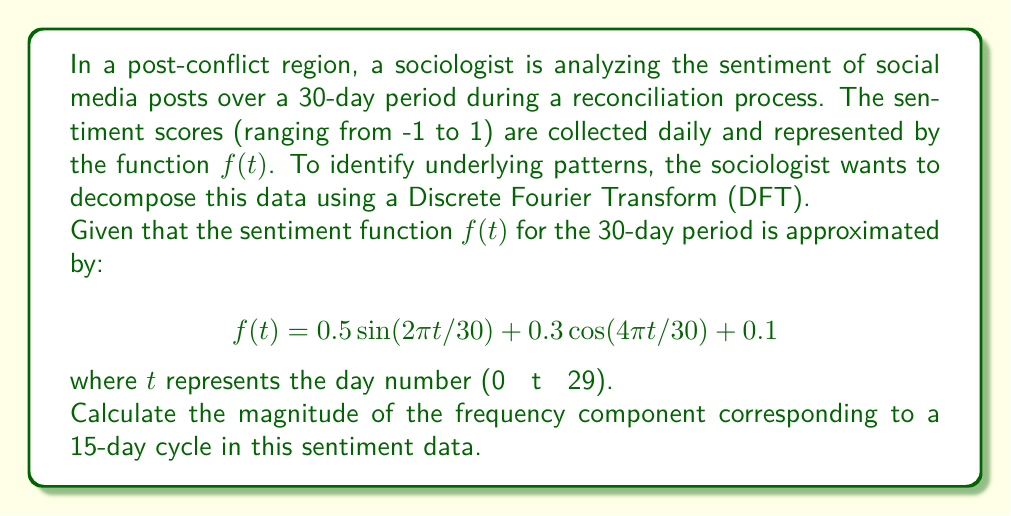Give your solution to this math problem. To solve this problem, we need to follow these steps:

1) First, we need to identify the frequencies in the given function. The function contains:
   - A sine term with period 30 days
   - A cosine term with period 15 days
   - A constant term

2) The question asks for the magnitude of the frequency component corresponding to a 15-day cycle. This is represented by the cosine term in our function.

3) In the context of DFT, the magnitude of a frequency component is given by the amplitude of its corresponding sine or cosine term.

4) The cosine term representing the 15-day cycle is:

   $$0.3 \cos(4\pi t/30)$$

5) The amplitude of this term is 0.3.

6) Therefore, the magnitude of the frequency component for the 15-day cycle is 0.3.

Note: In a more complex scenario, we would need to consider both sine and cosine terms for each frequency and calculate the magnitude as $\sqrt{a^2 + b^2}$, where $a$ and $b$ are the coefficients of the cosine and sine terms respectively. However, in this case, we only have a cosine term for the 15-day cycle, so the magnitude is simply the absolute value of its coefficient.
Answer: The magnitude of the frequency component corresponding to a 15-day cycle is 0.3. 